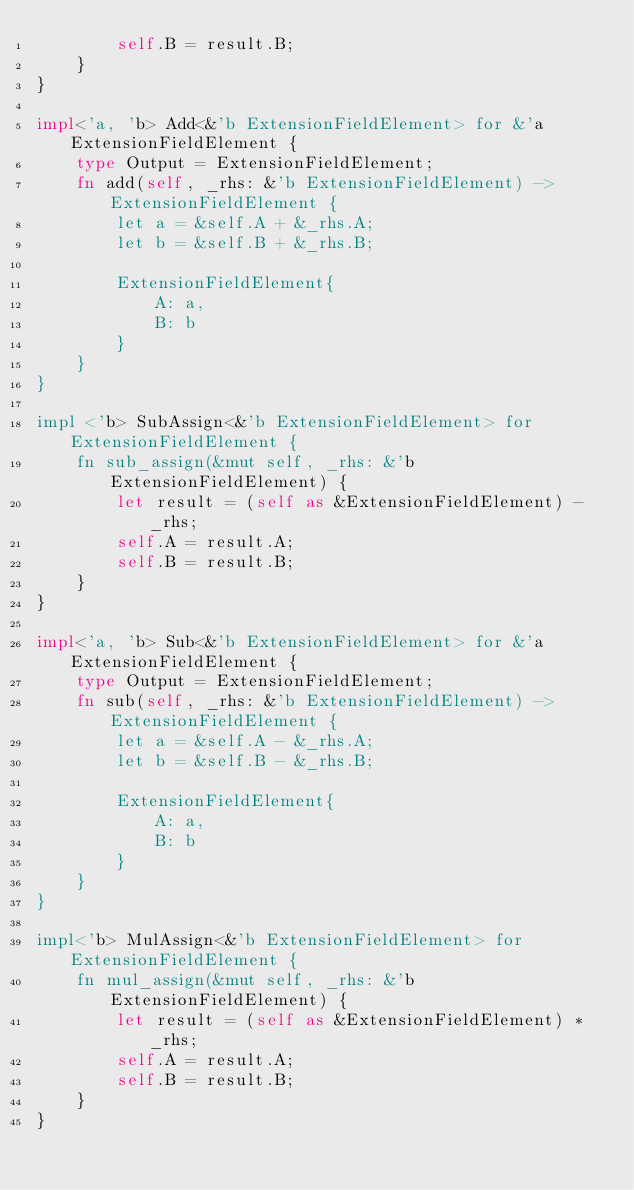<code> <loc_0><loc_0><loc_500><loc_500><_Rust_>        self.B = result.B;
    }
}

impl<'a, 'b> Add<&'b ExtensionFieldElement> for &'a ExtensionFieldElement {
    type Output = ExtensionFieldElement;
    fn add(self, _rhs: &'b ExtensionFieldElement) -> ExtensionFieldElement {
        let a = &self.A + &_rhs.A;
        let b = &self.B + &_rhs.B;

        ExtensionFieldElement{
            A: a,
            B: b
        }
    }
}

impl <'b> SubAssign<&'b ExtensionFieldElement> for ExtensionFieldElement {
    fn sub_assign(&mut self, _rhs: &'b ExtensionFieldElement) {
        let result = (self as &ExtensionFieldElement) - _rhs;
        self.A = result.A;
        self.B = result.B;
    }
}

impl<'a, 'b> Sub<&'b ExtensionFieldElement> for &'a ExtensionFieldElement {
    type Output = ExtensionFieldElement;
    fn sub(self, _rhs: &'b ExtensionFieldElement) -> ExtensionFieldElement {
        let a = &self.A - &_rhs.A;
        let b = &self.B - &_rhs.B;

        ExtensionFieldElement{
            A: a,
            B: b
        }
    }
}

impl<'b> MulAssign<&'b ExtensionFieldElement> for ExtensionFieldElement {
    fn mul_assign(&mut self, _rhs: &'b ExtensionFieldElement) {
        let result = (self as &ExtensionFieldElement) * _rhs;
        self.A = result.A;
        self.B = result.B;
    }
}
</code> 